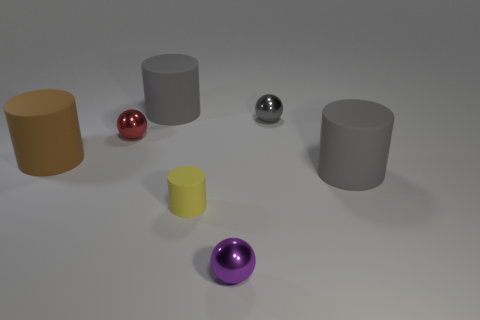There is a gray rubber object in front of the red thing; what size is it?
Keep it short and to the point. Large. There is a matte object that is behind the small red metal object; is it the same color as the small matte object?
Ensure brevity in your answer.  No. What number of tiny red metal things are the same shape as the yellow thing?
Your answer should be compact. 0. How many objects are big gray cylinders on the left side of the tiny yellow matte cylinder or large gray rubber cylinders behind the large brown object?
Ensure brevity in your answer.  1. How many cyan objects are metallic things or small cylinders?
Your response must be concise. 0. What is the material of the object that is both to the left of the yellow matte cylinder and behind the tiny red sphere?
Your answer should be very brief. Rubber. Do the purple ball and the small yellow thing have the same material?
Give a very brief answer. No. What number of red objects have the same size as the yellow object?
Offer a terse response. 1. Are there an equal number of gray things that are to the left of the brown cylinder and large blue balls?
Provide a succinct answer. Yes. What number of small things are both behind the brown matte cylinder and to the left of the tiny purple thing?
Offer a terse response. 1. 